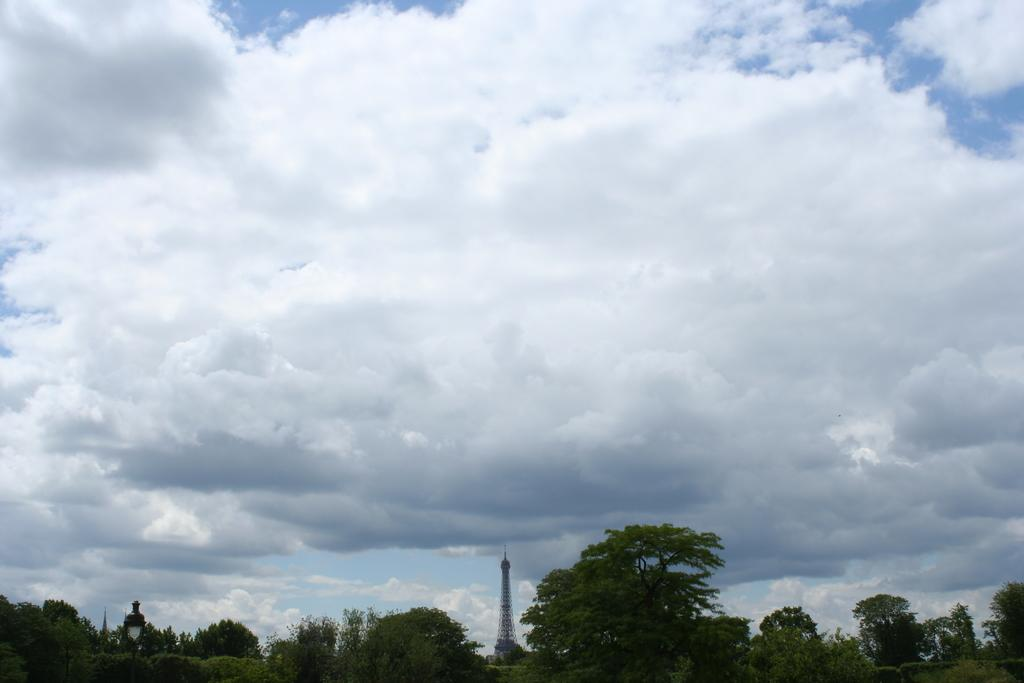What type of vegetation can be seen in the image? There are trees in the image. What structure is visible in the background of the image? There is a tower in the background of the image. What is visible at the top of the image? The sky is visible at the top of the image and appears to be cloudy. How many eyes can be seen on the cactus in the image? There is no cactus present in the image, so it is not possible to determine the number of eyes on a cactus. What type of transportation is available at the station in the image? There is no station present in the image, so it is not possible to determine the type of transportation available. 